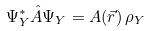<formula> <loc_0><loc_0><loc_500><loc_500>\Psi _ { Y } ^ { * } \hat { A } \Psi _ { Y } = A ( \vec { r } ) \, \rho _ { Y }</formula> 